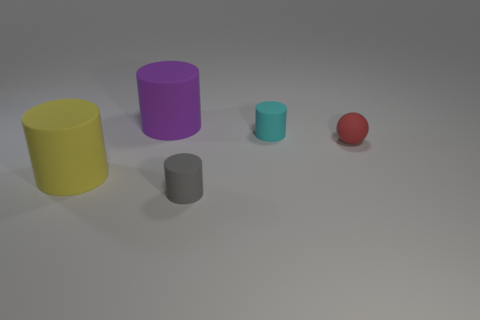Is the number of tiny balls less than the number of matte cylinders? yes 